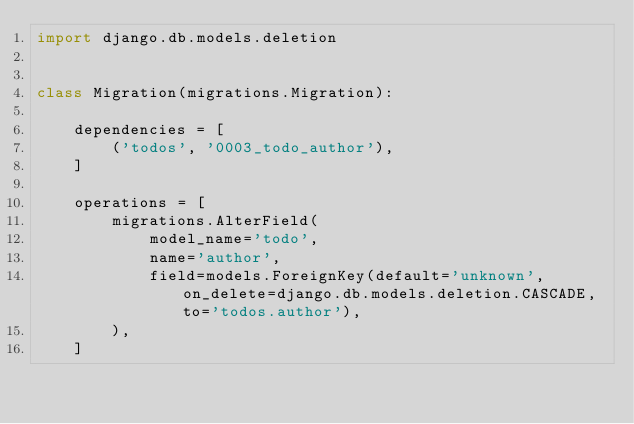Convert code to text. <code><loc_0><loc_0><loc_500><loc_500><_Python_>import django.db.models.deletion


class Migration(migrations.Migration):

    dependencies = [
        ('todos', '0003_todo_author'),
    ]

    operations = [
        migrations.AlterField(
            model_name='todo',
            name='author',
            field=models.ForeignKey(default='unknown', on_delete=django.db.models.deletion.CASCADE, to='todos.author'),
        ),
    ]
</code> 